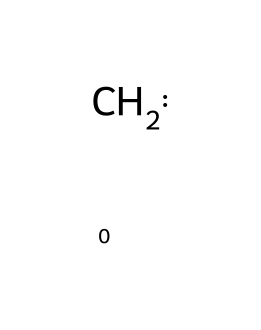What is the number of carbon atoms in this structure? The structure represented by the SMILES "[CH2]" indicates that it contains one carbon atom. The "C" in the SMILES notation corresponds to a single carbon atom.
Answer: 1 How many hydrogen atoms are bonded to the carbon in this structure? The SMILES notation "[CH2]" indicates that the carbon atom is bonded to two hydrogen atoms, as shown by "H2". Hence, there are two hydrogen atoms.
Answer: 2 What is the hybridization of the carbon atom in this carbene? In the structure "[CH2]", the carbon is connected to two hydrogens and has a lone pair, which leads to sp² hybridization, typical for carbenes.
Answer: sp² What is the geometry of the singlet carbene based on its hybridization? The sp² hybridization of carbon in this case leads to a trigonal planar geometry around the carbon atom. This is characteristic of carbenes in a singlet state.
Answer: trigonal planar Is this compound a stable carbene? The structure "[CH2]" represents a singlet carbene which is often less stable compared to its triplet form, thus indicating it is generally unstable.
Answer: unstable What type of chemical species does this structure represent? The SMILES "[CH2]" symbolizes a carbene, which is characterized by having a divalent carbon atom with only two substituents, in this case, two hydrogen atoms.
Answer: carbene How does the electron configuration influence the reactivity of this carbene? The lone pair of electrons on the carbon atom in this structure makes it a nucleophilic species, thus increasing its reactivity in chemical reactions.
Answer: nucleophilic 